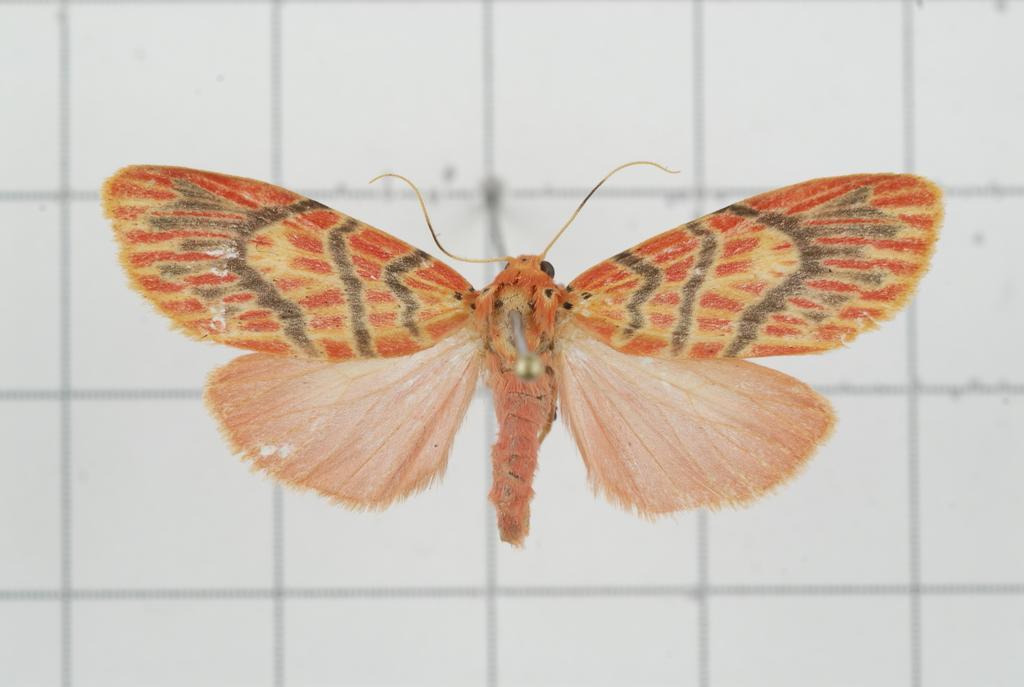Please provide a concise description of this image. In this picture there is a butterfly in the center of the image. 